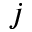<formula> <loc_0><loc_0><loc_500><loc_500>j</formula> 